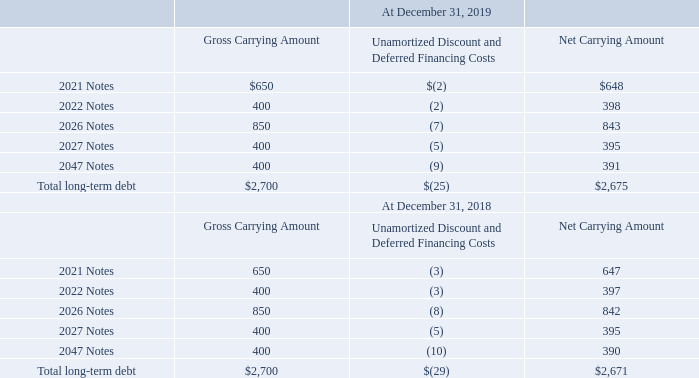Interest expense and financing costs
Fees and discounts associated with the issuance of our debt instruments are recorded as debt discount, which reduces their respective carrying values, and are amortized over their respective terms. Amortization expense is recorded within “Interest and other expense (income), net” in our consolidated statement of operations.
For the years ended December 31, 2019, 2018, and 2017: interest expense was $86 million, $134 million, and $150 million, respectively; amortization of the debt discount and deferred financing costs was $4 million, $6 million, and $12 million, respectively.
A summary of our outstanding debt is as follows (amounts in millions):
With the exception of the 2026 and the 2047 Notes, using Level 2 inputs (i.e., observable market prices in less-than-active markets) at December 31, 2019, the carrying values of the Notes approximated their fair values, as the interest rates were similar to the current rates at which we could borrow funds over the selected interest periods. At December 31, 2019, based on Level 2 inputs, the fair value of the 2026 and the 2047 Notes were $893 million and $456 million, respectively.
Using Level 2 inputs at December 31, 2018, the carrying values of the 2021 Notes and the 2022 Notes approximated their fair values, as the interest rates were similar to the current rates at which we could borrow funds over the selected interest periods. At December 31, 2019, based on Level 2 inputs, the fair values of the 2026 Notes, the 2027 Notes, and the 2047 Notes were $800 million, $376 million, and $360 million, respectively.
What were fees and discounts associated with the issuance of the company's debt instruments recorded as? Debt discount, which reduces their respective carrying values, and are amortized over their respective terms. What was the interest expense for 2019? $86 million. What was the interest expense for 2018? $134 million. What was the change in the gross carrying amount between the 2021 and 2022 Notes in 2019?
Answer scale should be: million. 400-650
Answer: -250. What was the change in the net carrying amount between the 2026 and 2027 Notes in 2018?
Answer scale should be: million. 395-842
Answer: -447. What was the percentage change in the net carrying amount of total long-term debt between 2018 and 2019?
Answer scale should be: percent. ($2,675-$2,671)/$2,671
Answer: 0.15. 